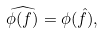Convert formula to latex. <formula><loc_0><loc_0><loc_500><loc_500>\widehat { \phi ( f ) } = \phi ( \hat { f } ) ,</formula> 